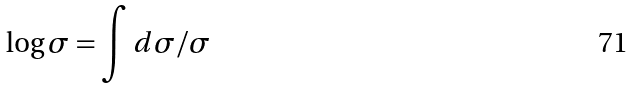Convert formula to latex. <formula><loc_0><loc_0><loc_500><loc_500>\log \sigma = \int d \sigma / \sigma</formula> 